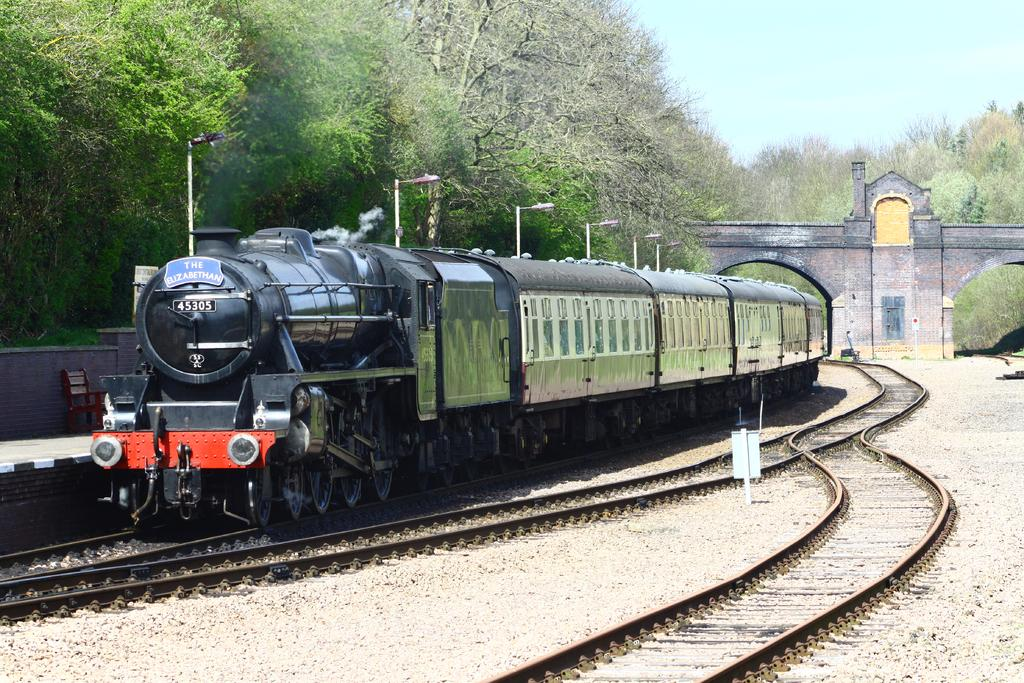What is the main subject of the image? The main subject of the image is a train on a track. What other objects or structures can be seen in the image? There are poles, lights, boards, tracks, a chair on the platform, trees, and a bridge visible in the image. What is the background of the image? The sky is visible in the background of the image. What type of skate is being used by the train in the image? There is no skate present in the image; it features a train on a track. What kind of shock can be seen affecting the trees in the image? There is no shock affecting the trees in the image; they appear to be standing normally. 